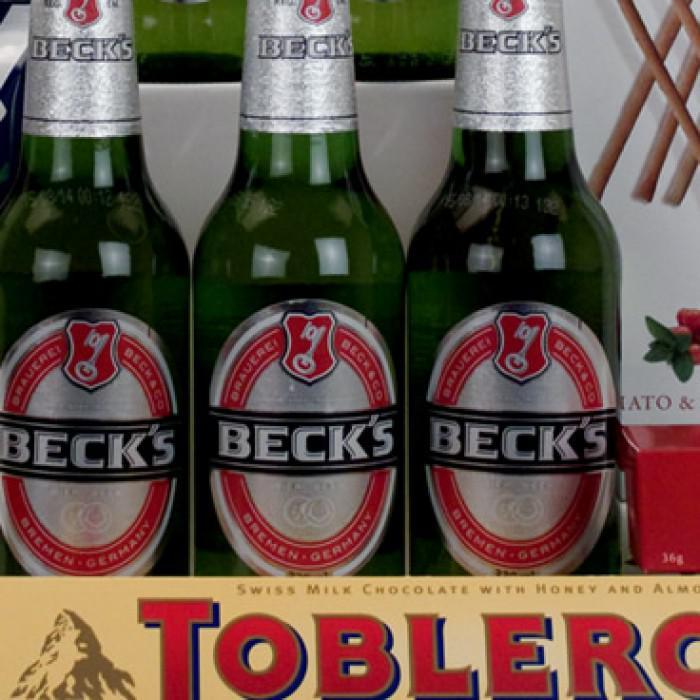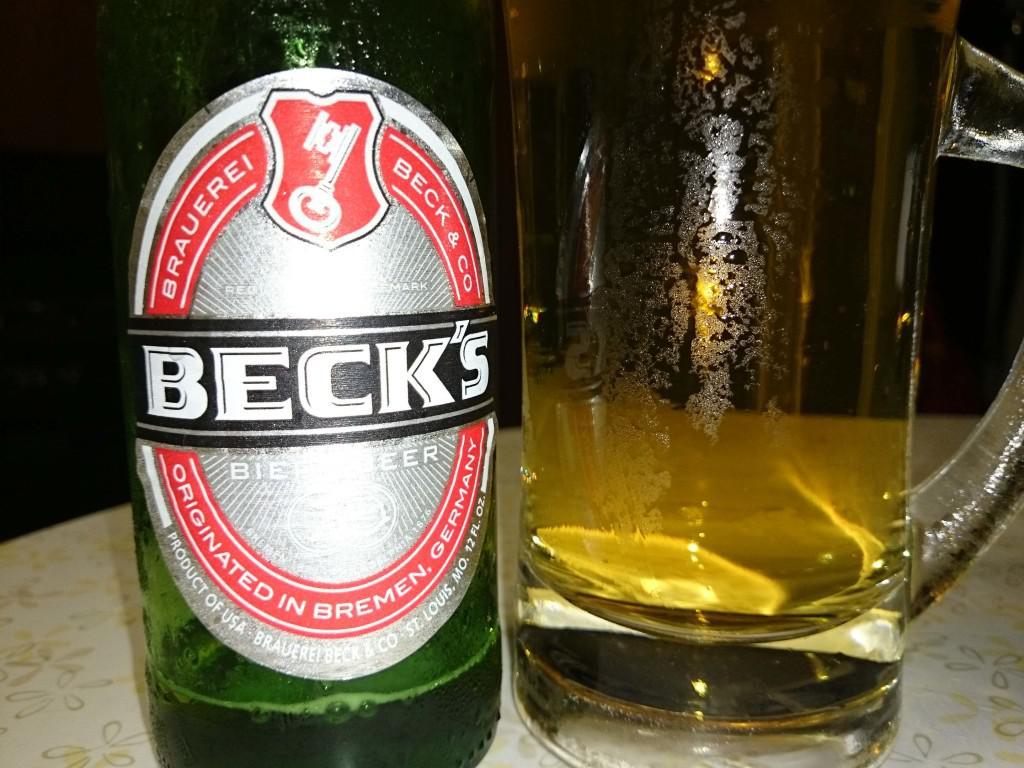The first image is the image on the left, the second image is the image on the right. For the images shown, is this caption "Some of the beer is served in a glass, and some is still in bottles." true? Answer yes or no. Yes. The first image is the image on the left, the second image is the image on the right. Examine the images to the left and right. Is the description "Four or fewer beer bottles are visible." accurate? Answer yes or no. Yes. 